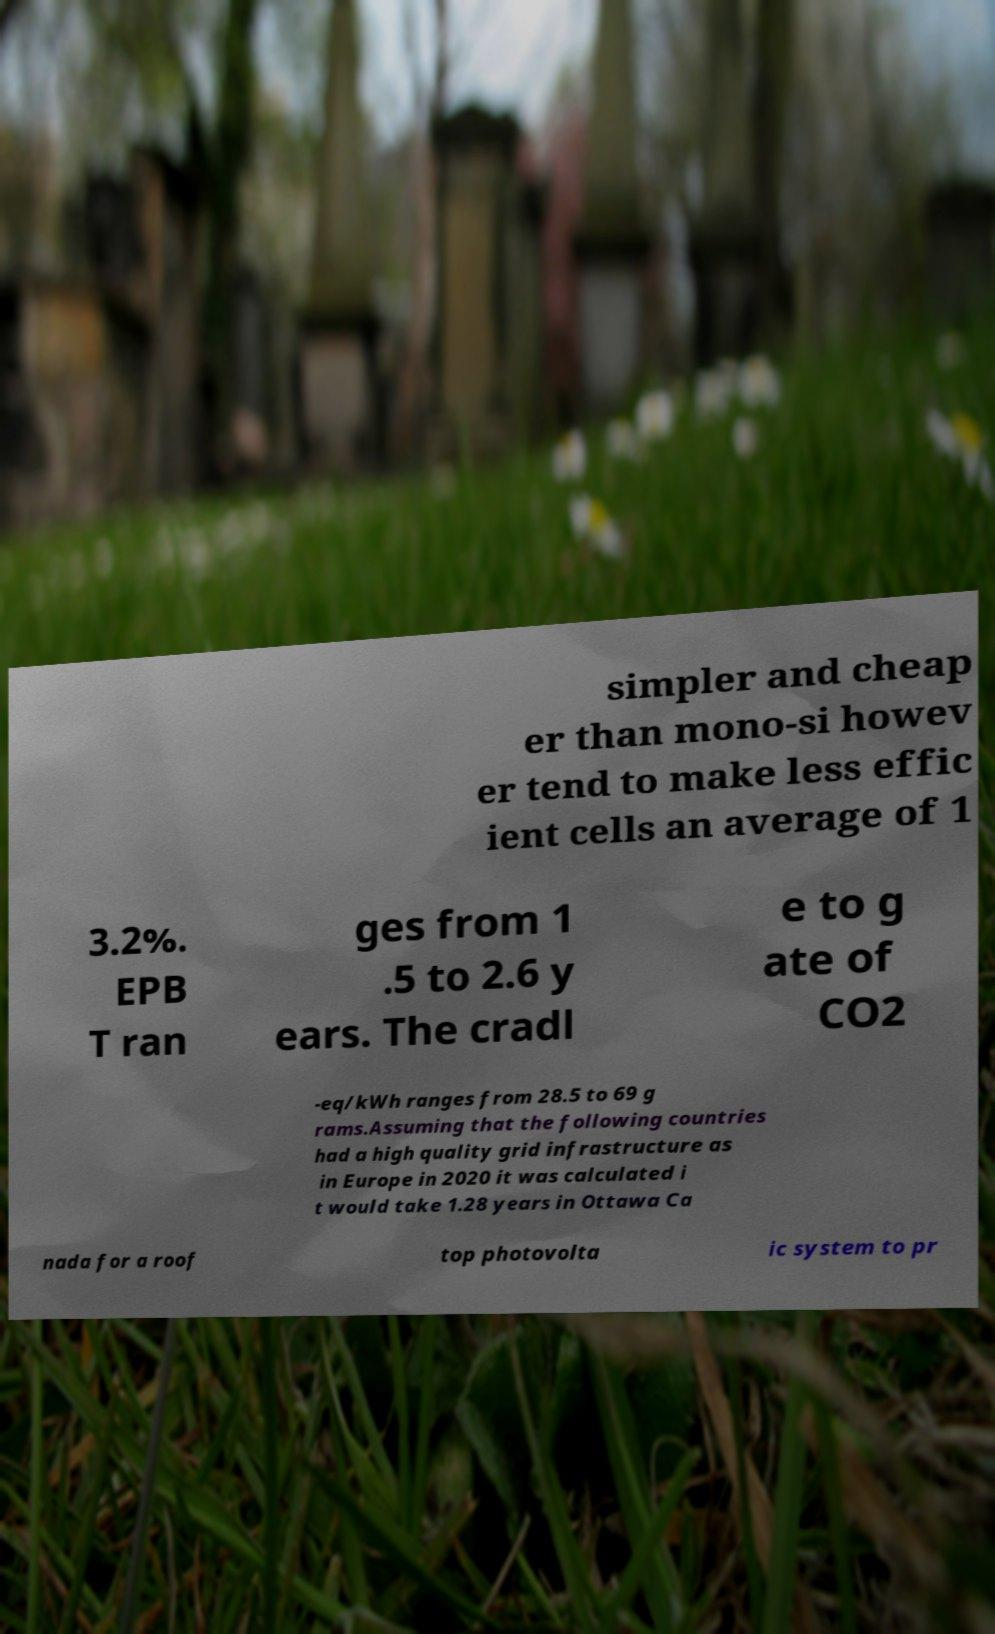What messages or text are displayed in this image? I need them in a readable, typed format. simpler and cheap er than mono-si howev er tend to make less effic ient cells an average of 1 3.2%. EPB T ran ges from 1 .5 to 2.6 y ears. The cradl e to g ate of CO2 -eq/kWh ranges from 28.5 to 69 g rams.Assuming that the following countries had a high quality grid infrastructure as in Europe in 2020 it was calculated i t would take 1.28 years in Ottawa Ca nada for a roof top photovolta ic system to pr 